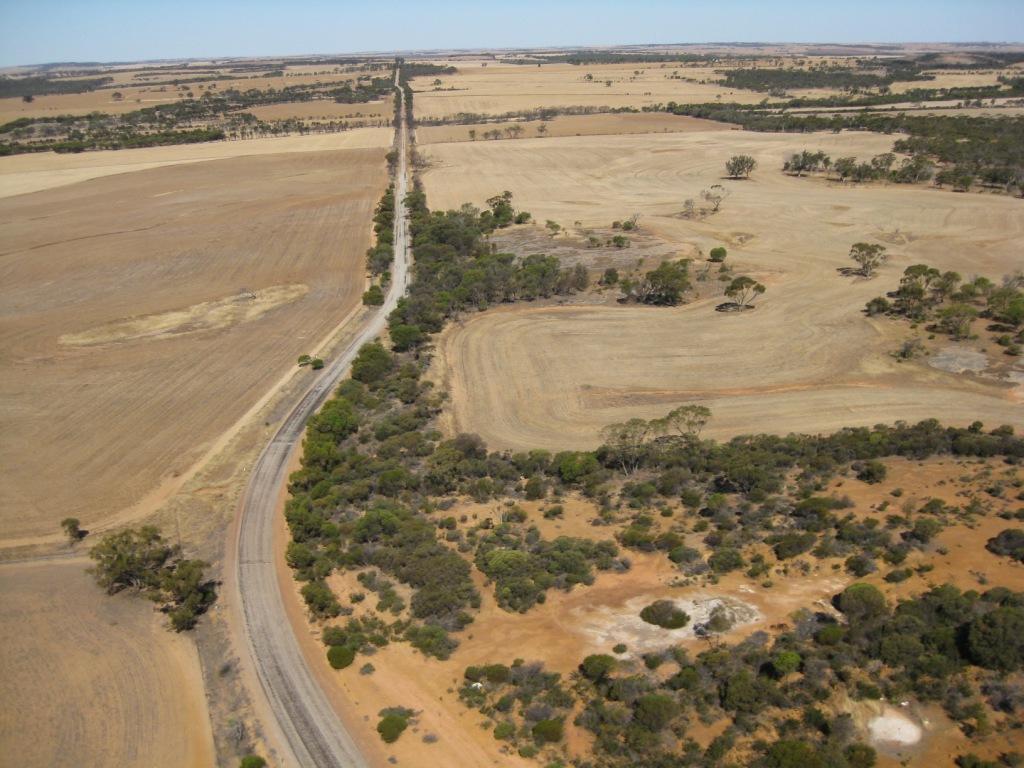Could you give a brief overview of what you see in this image? In this picture I can see road, there are trees, and in the background there is the sky. 